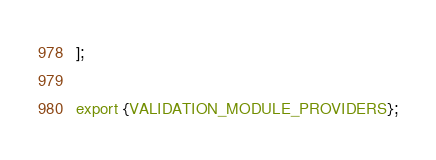Convert code to text. <code><loc_0><loc_0><loc_500><loc_500><_TypeScript_>];

export {VALIDATION_MODULE_PROVIDERS};
</code> 